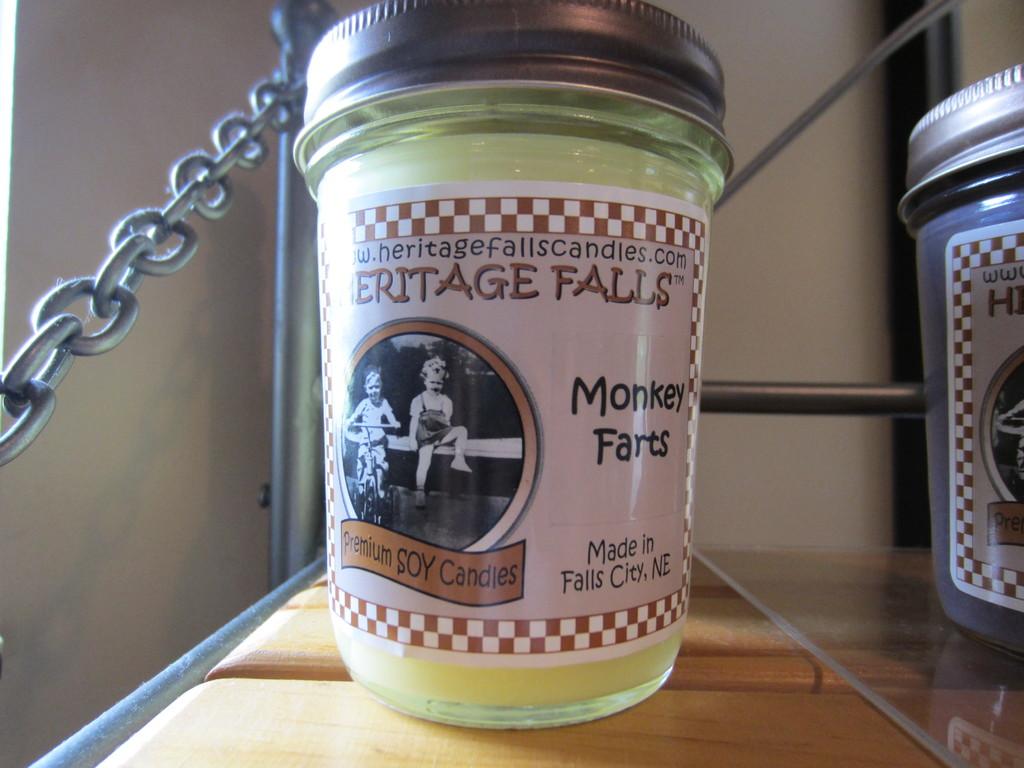Who makes this candle?
Offer a terse response. Heritage falls. 